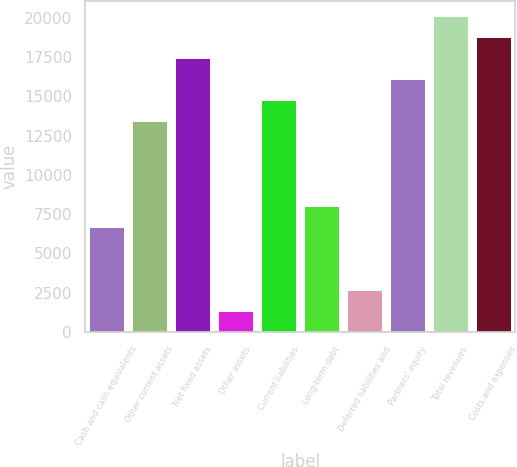<chart> <loc_0><loc_0><loc_500><loc_500><bar_chart><fcel>Cash and cash equivalents<fcel>Other current assets<fcel>Net fixed assets<fcel>Other assets<fcel>Current liabilities<fcel>Long-term debt<fcel>Deferred liabilities and<fcel>Partners' equity<fcel>Total revenues<fcel>Costs and expenses<nl><fcel>6703.5<fcel>13396<fcel>17411.5<fcel>1349.5<fcel>14734.5<fcel>8042<fcel>2688<fcel>16073<fcel>20088.5<fcel>18750<nl></chart> 